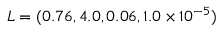Convert formula to latex. <formula><loc_0><loc_0><loc_500><loc_500>L = ( 0 . 7 6 , 4 . 0 , 0 . 0 6 , 1 . 0 \times 1 0 ^ { - 5 } )</formula> 